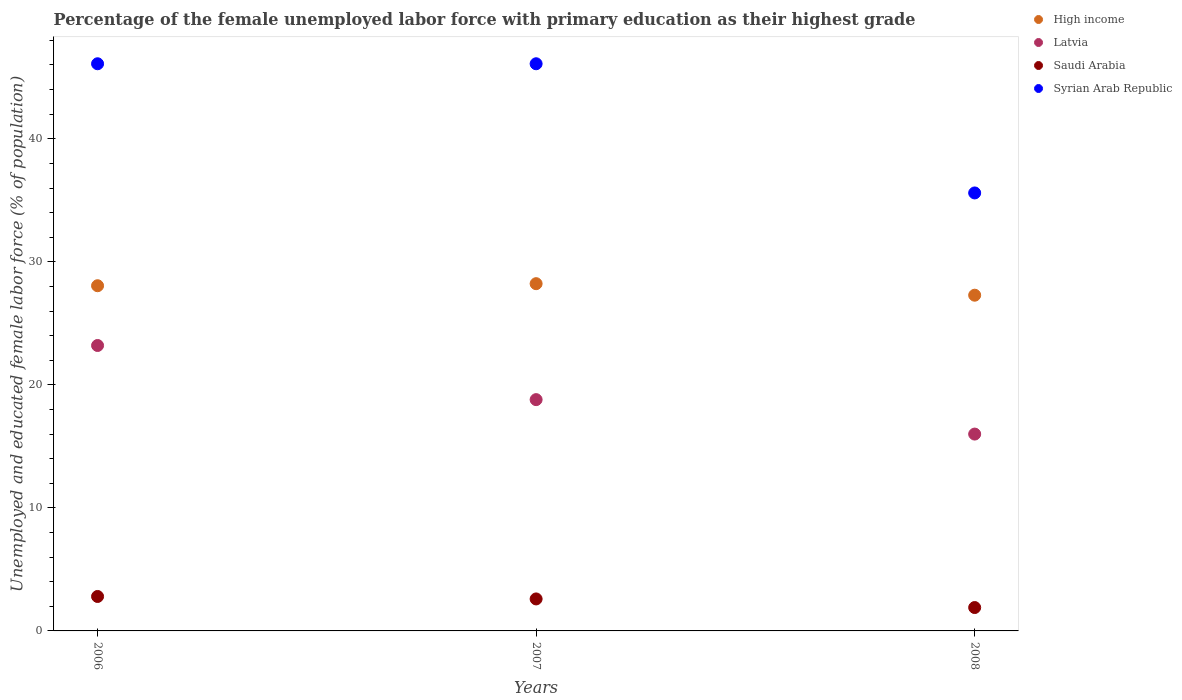What is the percentage of the unemployed female labor force with primary education in High income in 2008?
Provide a succinct answer. 27.29. Across all years, what is the maximum percentage of the unemployed female labor force with primary education in Saudi Arabia?
Offer a terse response. 2.8. Across all years, what is the minimum percentage of the unemployed female labor force with primary education in Latvia?
Offer a terse response. 16. What is the total percentage of the unemployed female labor force with primary education in Syrian Arab Republic in the graph?
Give a very brief answer. 127.8. What is the difference between the percentage of the unemployed female labor force with primary education in Syrian Arab Republic in 2007 and that in 2008?
Your response must be concise. 10.5. What is the difference between the percentage of the unemployed female labor force with primary education in Syrian Arab Republic in 2007 and the percentage of the unemployed female labor force with primary education in Latvia in 2008?
Offer a terse response. 30.1. What is the average percentage of the unemployed female labor force with primary education in Saudi Arabia per year?
Your answer should be very brief. 2.43. In the year 2006, what is the difference between the percentage of the unemployed female labor force with primary education in Latvia and percentage of the unemployed female labor force with primary education in Syrian Arab Republic?
Give a very brief answer. -22.9. In how many years, is the percentage of the unemployed female labor force with primary education in Syrian Arab Republic greater than 36 %?
Your answer should be compact. 2. What is the ratio of the percentage of the unemployed female labor force with primary education in Syrian Arab Republic in 2006 to that in 2008?
Provide a succinct answer. 1.29. What is the difference between the highest and the second highest percentage of the unemployed female labor force with primary education in Latvia?
Keep it short and to the point. 4.4. What is the difference between the highest and the lowest percentage of the unemployed female labor force with primary education in Latvia?
Ensure brevity in your answer.  7.2. Is the sum of the percentage of the unemployed female labor force with primary education in Syrian Arab Republic in 2007 and 2008 greater than the maximum percentage of the unemployed female labor force with primary education in High income across all years?
Ensure brevity in your answer.  Yes. Does the percentage of the unemployed female labor force with primary education in Latvia monotonically increase over the years?
Provide a short and direct response. No. How many years are there in the graph?
Your response must be concise. 3. What is the difference between two consecutive major ticks on the Y-axis?
Offer a terse response. 10. Are the values on the major ticks of Y-axis written in scientific E-notation?
Keep it short and to the point. No. Does the graph contain any zero values?
Your answer should be compact. No. Where does the legend appear in the graph?
Provide a succinct answer. Top right. What is the title of the graph?
Offer a terse response. Percentage of the female unemployed labor force with primary education as their highest grade. Does "Uzbekistan" appear as one of the legend labels in the graph?
Offer a terse response. No. What is the label or title of the Y-axis?
Provide a succinct answer. Unemployed and educated female labor force (% of population). What is the Unemployed and educated female labor force (% of population) of High income in 2006?
Give a very brief answer. 28.06. What is the Unemployed and educated female labor force (% of population) of Latvia in 2006?
Your response must be concise. 23.2. What is the Unemployed and educated female labor force (% of population) in Saudi Arabia in 2006?
Your answer should be compact. 2.8. What is the Unemployed and educated female labor force (% of population) of Syrian Arab Republic in 2006?
Your response must be concise. 46.1. What is the Unemployed and educated female labor force (% of population) of High income in 2007?
Give a very brief answer. 28.22. What is the Unemployed and educated female labor force (% of population) of Latvia in 2007?
Offer a terse response. 18.8. What is the Unemployed and educated female labor force (% of population) of Saudi Arabia in 2007?
Keep it short and to the point. 2.6. What is the Unemployed and educated female labor force (% of population) in Syrian Arab Republic in 2007?
Offer a very short reply. 46.1. What is the Unemployed and educated female labor force (% of population) of High income in 2008?
Your answer should be very brief. 27.29. What is the Unemployed and educated female labor force (% of population) in Saudi Arabia in 2008?
Give a very brief answer. 1.9. What is the Unemployed and educated female labor force (% of population) in Syrian Arab Republic in 2008?
Ensure brevity in your answer.  35.6. Across all years, what is the maximum Unemployed and educated female labor force (% of population) in High income?
Provide a succinct answer. 28.22. Across all years, what is the maximum Unemployed and educated female labor force (% of population) in Latvia?
Offer a very short reply. 23.2. Across all years, what is the maximum Unemployed and educated female labor force (% of population) of Saudi Arabia?
Your answer should be very brief. 2.8. Across all years, what is the maximum Unemployed and educated female labor force (% of population) of Syrian Arab Republic?
Make the answer very short. 46.1. Across all years, what is the minimum Unemployed and educated female labor force (% of population) of High income?
Give a very brief answer. 27.29. Across all years, what is the minimum Unemployed and educated female labor force (% of population) in Latvia?
Make the answer very short. 16. Across all years, what is the minimum Unemployed and educated female labor force (% of population) in Saudi Arabia?
Provide a short and direct response. 1.9. Across all years, what is the minimum Unemployed and educated female labor force (% of population) of Syrian Arab Republic?
Offer a very short reply. 35.6. What is the total Unemployed and educated female labor force (% of population) in High income in the graph?
Your response must be concise. 83.57. What is the total Unemployed and educated female labor force (% of population) of Latvia in the graph?
Ensure brevity in your answer.  58. What is the total Unemployed and educated female labor force (% of population) in Syrian Arab Republic in the graph?
Provide a succinct answer. 127.8. What is the difference between the Unemployed and educated female labor force (% of population) in High income in 2006 and that in 2007?
Provide a short and direct response. -0.17. What is the difference between the Unemployed and educated female labor force (% of population) of High income in 2006 and that in 2008?
Offer a terse response. 0.77. What is the difference between the Unemployed and educated female labor force (% of population) in Latvia in 2006 and that in 2008?
Ensure brevity in your answer.  7.2. What is the difference between the Unemployed and educated female labor force (% of population) of Syrian Arab Republic in 2006 and that in 2008?
Offer a terse response. 10.5. What is the difference between the Unemployed and educated female labor force (% of population) of High income in 2007 and that in 2008?
Offer a terse response. 0.94. What is the difference between the Unemployed and educated female labor force (% of population) of Syrian Arab Republic in 2007 and that in 2008?
Give a very brief answer. 10.5. What is the difference between the Unemployed and educated female labor force (% of population) of High income in 2006 and the Unemployed and educated female labor force (% of population) of Latvia in 2007?
Give a very brief answer. 9.26. What is the difference between the Unemployed and educated female labor force (% of population) in High income in 2006 and the Unemployed and educated female labor force (% of population) in Saudi Arabia in 2007?
Provide a succinct answer. 25.46. What is the difference between the Unemployed and educated female labor force (% of population) of High income in 2006 and the Unemployed and educated female labor force (% of population) of Syrian Arab Republic in 2007?
Keep it short and to the point. -18.04. What is the difference between the Unemployed and educated female labor force (% of population) in Latvia in 2006 and the Unemployed and educated female labor force (% of population) in Saudi Arabia in 2007?
Provide a short and direct response. 20.6. What is the difference between the Unemployed and educated female labor force (% of population) of Latvia in 2006 and the Unemployed and educated female labor force (% of population) of Syrian Arab Republic in 2007?
Offer a very short reply. -22.9. What is the difference between the Unemployed and educated female labor force (% of population) in Saudi Arabia in 2006 and the Unemployed and educated female labor force (% of population) in Syrian Arab Republic in 2007?
Your response must be concise. -43.3. What is the difference between the Unemployed and educated female labor force (% of population) of High income in 2006 and the Unemployed and educated female labor force (% of population) of Latvia in 2008?
Offer a terse response. 12.06. What is the difference between the Unemployed and educated female labor force (% of population) in High income in 2006 and the Unemployed and educated female labor force (% of population) in Saudi Arabia in 2008?
Your answer should be compact. 26.16. What is the difference between the Unemployed and educated female labor force (% of population) of High income in 2006 and the Unemployed and educated female labor force (% of population) of Syrian Arab Republic in 2008?
Provide a short and direct response. -7.54. What is the difference between the Unemployed and educated female labor force (% of population) in Latvia in 2006 and the Unemployed and educated female labor force (% of population) in Saudi Arabia in 2008?
Provide a succinct answer. 21.3. What is the difference between the Unemployed and educated female labor force (% of population) in Latvia in 2006 and the Unemployed and educated female labor force (% of population) in Syrian Arab Republic in 2008?
Provide a short and direct response. -12.4. What is the difference between the Unemployed and educated female labor force (% of population) in Saudi Arabia in 2006 and the Unemployed and educated female labor force (% of population) in Syrian Arab Republic in 2008?
Provide a succinct answer. -32.8. What is the difference between the Unemployed and educated female labor force (% of population) in High income in 2007 and the Unemployed and educated female labor force (% of population) in Latvia in 2008?
Give a very brief answer. 12.22. What is the difference between the Unemployed and educated female labor force (% of population) of High income in 2007 and the Unemployed and educated female labor force (% of population) of Saudi Arabia in 2008?
Your response must be concise. 26.32. What is the difference between the Unemployed and educated female labor force (% of population) of High income in 2007 and the Unemployed and educated female labor force (% of population) of Syrian Arab Republic in 2008?
Offer a very short reply. -7.38. What is the difference between the Unemployed and educated female labor force (% of population) in Latvia in 2007 and the Unemployed and educated female labor force (% of population) in Syrian Arab Republic in 2008?
Give a very brief answer. -16.8. What is the difference between the Unemployed and educated female labor force (% of population) of Saudi Arabia in 2007 and the Unemployed and educated female labor force (% of population) of Syrian Arab Republic in 2008?
Provide a short and direct response. -33. What is the average Unemployed and educated female labor force (% of population) of High income per year?
Keep it short and to the point. 27.86. What is the average Unemployed and educated female labor force (% of population) in Latvia per year?
Keep it short and to the point. 19.33. What is the average Unemployed and educated female labor force (% of population) in Saudi Arabia per year?
Ensure brevity in your answer.  2.43. What is the average Unemployed and educated female labor force (% of population) in Syrian Arab Republic per year?
Make the answer very short. 42.6. In the year 2006, what is the difference between the Unemployed and educated female labor force (% of population) of High income and Unemployed and educated female labor force (% of population) of Latvia?
Provide a short and direct response. 4.86. In the year 2006, what is the difference between the Unemployed and educated female labor force (% of population) of High income and Unemployed and educated female labor force (% of population) of Saudi Arabia?
Offer a terse response. 25.26. In the year 2006, what is the difference between the Unemployed and educated female labor force (% of population) in High income and Unemployed and educated female labor force (% of population) in Syrian Arab Republic?
Make the answer very short. -18.04. In the year 2006, what is the difference between the Unemployed and educated female labor force (% of population) of Latvia and Unemployed and educated female labor force (% of population) of Saudi Arabia?
Keep it short and to the point. 20.4. In the year 2006, what is the difference between the Unemployed and educated female labor force (% of population) in Latvia and Unemployed and educated female labor force (% of population) in Syrian Arab Republic?
Offer a terse response. -22.9. In the year 2006, what is the difference between the Unemployed and educated female labor force (% of population) in Saudi Arabia and Unemployed and educated female labor force (% of population) in Syrian Arab Republic?
Make the answer very short. -43.3. In the year 2007, what is the difference between the Unemployed and educated female labor force (% of population) of High income and Unemployed and educated female labor force (% of population) of Latvia?
Offer a terse response. 9.42. In the year 2007, what is the difference between the Unemployed and educated female labor force (% of population) in High income and Unemployed and educated female labor force (% of population) in Saudi Arabia?
Provide a succinct answer. 25.62. In the year 2007, what is the difference between the Unemployed and educated female labor force (% of population) of High income and Unemployed and educated female labor force (% of population) of Syrian Arab Republic?
Provide a succinct answer. -17.88. In the year 2007, what is the difference between the Unemployed and educated female labor force (% of population) in Latvia and Unemployed and educated female labor force (% of population) in Syrian Arab Republic?
Keep it short and to the point. -27.3. In the year 2007, what is the difference between the Unemployed and educated female labor force (% of population) in Saudi Arabia and Unemployed and educated female labor force (% of population) in Syrian Arab Republic?
Your answer should be very brief. -43.5. In the year 2008, what is the difference between the Unemployed and educated female labor force (% of population) of High income and Unemployed and educated female labor force (% of population) of Latvia?
Offer a very short reply. 11.29. In the year 2008, what is the difference between the Unemployed and educated female labor force (% of population) of High income and Unemployed and educated female labor force (% of population) of Saudi Arabia?
Give a very brief answer. 25.39. In the year 2008, what is the difference between the Unemployed and educated female labor force (% of population) of High income and Unemployed and educated female labor force (% of population) of Syrian Arab Republic?
Provide a short and direct response. -8.31. In the year 2008, what is the difference between the Unemployed and educated female labor force (% of population) of Latvia and Unemployed and educated female labor force (% of population) of Saudi Arabia?
Ensure brevity in your answer.  14.1. In the year 2008, what is the difference between the Unemployed and educated female labor force (% of population) in Latvia and Unemployed and educated female labor force (% of population) in Syrian Arab Republic?
Make the answer very short. -19.6. In the year 2008, what is the difference between the Unemployed and educated female labor force (% of population) of Saudi Arabia and Unemployed and educated female labor force (% of population) of Syrian Arab Republic?
Offer a very short reply. -33.7. What is the ratio of the Unemployed and educated female labor force (% of population) of Latvia in 2006 to that in 2007?
Offer a very short reply. 1.23. What is the ratio of the Unemployed and educated female labor force (% of population) in Syrian Arab Republic in 2006 to that in 2007?
Offer a terse response. 1. What is the ratio of the Unemployed and educated female labor force (% of population) in High income in 2006 to that in 2008?
Provide a short and direct response. 1.03. What is the ratio of the Unemployed and educated female labor force (% of population) of Latvia in 2006 to that in 2008?
Your answer should be very brief. 1.45. What is the ratio of the Unemployed and educated female labor force (% of population) in Saudi Arabia in 2006 to that in 2008?
Your answer should be compact. 1.47. What is the ratio of the Unemployed and educated female labor force (% of population) in Syrian Arab Republic in 2006 to that in 2008?
Your answer should be very brief. 1.29. What is the ratio of the Unemployed and educated female labor force (% of population) in High income in 2007 to that in 2008?
Your response must be concise. 1.03. What is the ratio of the Unemployed and educated female labor force (% of population) of Latvia in 2007 to that in 2008?
Your answer should be compact. 1.18. What is the ratio of the Unemployed and educated female labor force (% of population) of Saudi Arabia in 2007 to that in 2008?
Provide a short and direct response. 1.37. What is the ratio of the Unemployed and educated female labor force (% of population) of Syrian Arab Republic in 2007 to that in 2008?
Offer a terse response. 1.29. What is the difference between the highest and the second highest Unemployed and educated female labor force (% of population) in High income?
Provide a short and direct response. 0.17. What is the difference between the highest and the second highest Unemployed and educated female labor force (% of population) in Latvia?
Offer a terse response. 4.4. What is the difference between the highest and the lowest Unemployed and educated female labor force (% of population) of High income?
Provide a short and direct response. 0.94. What is the difference between the highest and the lowest Unemployed and educated female labor force (% of population) of Latvia?
Provide a succinct answer. 7.2. What is the difference between the highest and the lowest Unemployed and educated female labor force (% of population) in Saudi Arabia?
Keep it short and to the point. 0.9. 